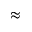<formula> <loc_0><loc_0><loc_500><loc_500>\approx</formula> 